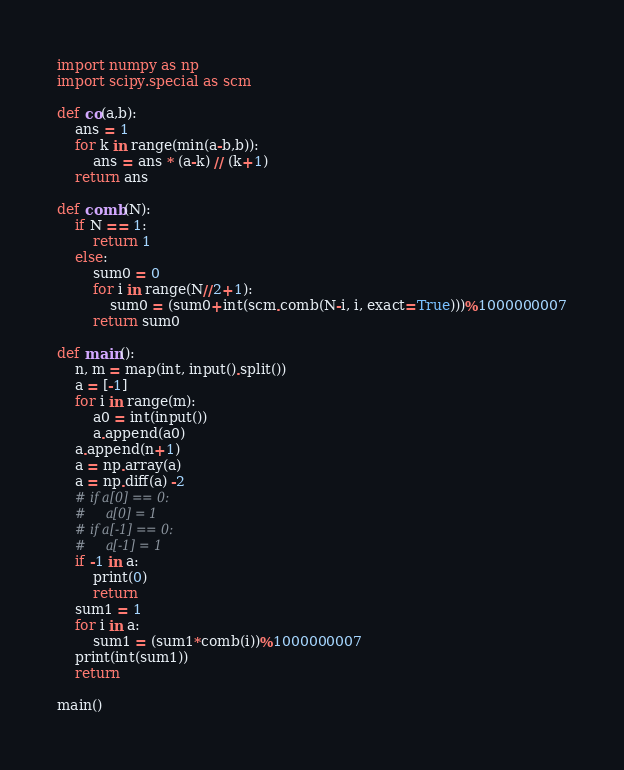<code> <loc_0><loc_0><loc_500><loc_500><_Python_>import numpy as np
import scipy.special as scm

def co(a,b):
    ans = 1
    for k in range(min(a-b,b)):
        ans = ans * (a-k) // (k+1)
    return ans

def comb(N):
    if N == 1:
        return 1
    else:
        sum0 = 0
        for i in range(N//2+1):
            sum0 = (sum0+int(scm.comb(N-i, i, exact=True)))%1000000007
        return sum0

def main():
    n, m = map(int, input().split())
    a = [-1]
    for i in range(m):
        a0 = int(input())
        a.append(a0)
    a.append(n+1)
    a = np.array(a)
    a = np.diff(a) -2
    # if a[0] == 0:
    #     a[0] = 1
    # if a[-1] == 0:
    #     a[-1] = 1
    if -1 in a:
        print(0)
        return
    sum1 = 1
    for i in a:
        sum1 = (sum1*comb(i))%1000000007
    print(int(sum1))
    return

main()
</code> 